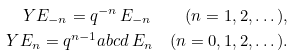<formula> <loc_0><loc_0><loc_500><loc_500>Y E _ { - n } = q ^ { - n } \, E _ { - n } \quad ( n = 1 , 2 , \dots ) , \\ Y E _ { n } = q ^ { n - 1 } a b c d \, E _ { n } \quad ( n = 0 , 1 , 2 , \dots ) .</formula> 